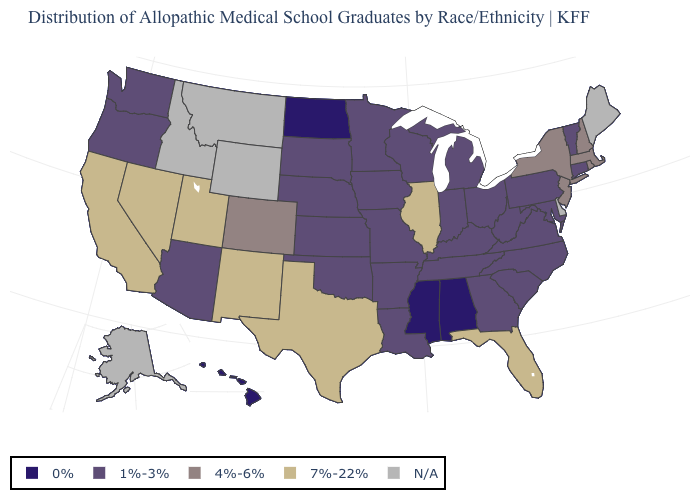What is the highest value in the MidWest ?
Give a very brief answer. 7%-22%. What is the value of Virginia?
Answer briefly. 1%-3%. What is the value of Delaware?
Keep it brief. N/A. Is the legend a continuous bar?
Quick response, please. No. Among the states that border Utah , does Nevada have the highest value?
Quick response, please. Yes. Name the states that have a value in the range 7%-22%?
Short answer required. California, Florida, Illinois, Nevada, New Mexico, Texas, Utah. Which states have the lowest value in the West?
Quick response, please. Hawaii. What is the value of North Carolina?
Short answer required. 1%-3%. Does Massachusetts have the highest value in the Northeast?
Keep it brief. Yes. Among the states that border Mississippi , which have the lowest value?
Keep it brief. Alabama. Name the states that have a value in the range 7%-22%?
Short answer required. California, Florida, Illinois, Nevada, New Mexico, Texas, Utah. What is the value of Missouri?
Answer briefly. 1%-3%. Which states have the lowest value in the USA?
Write a very short answer. Alabama, Hawaii, Mississippi, North Dakota. Which states have the highest value in the USA?
Answer briefly. California, Florida, Illinois, Nevada, New Mexico, Texas, Utah. 